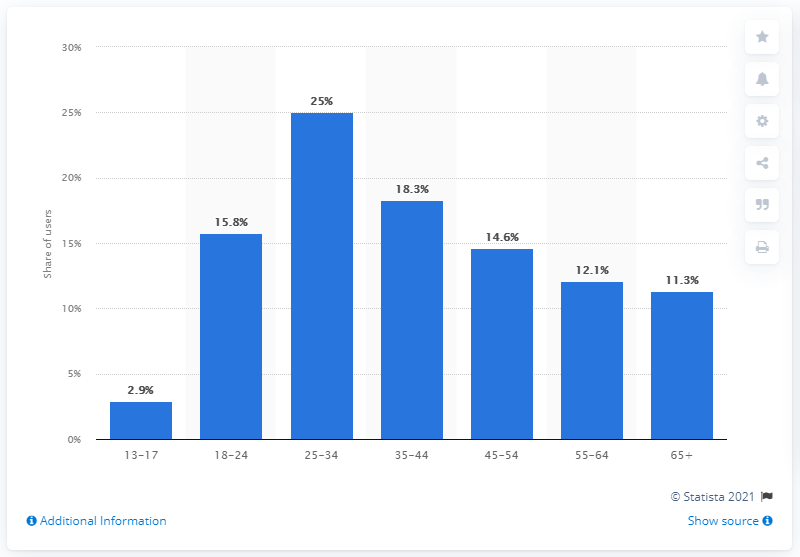Outline some significant characteristics in this image. The percentage difference between the 13 to 17 year old and 25 to 34 year old age groups is 22.1%. As of April 2021, approximately 25% of Facebook users were 25 to 34 years old. The age range of Facebook users is typically between 13 and 17 years old, with the lowest age being 13 and the highest age being 17. As of April 2021, approximately 25% of Facebook users were between the ages of 25 and 34 years old. 